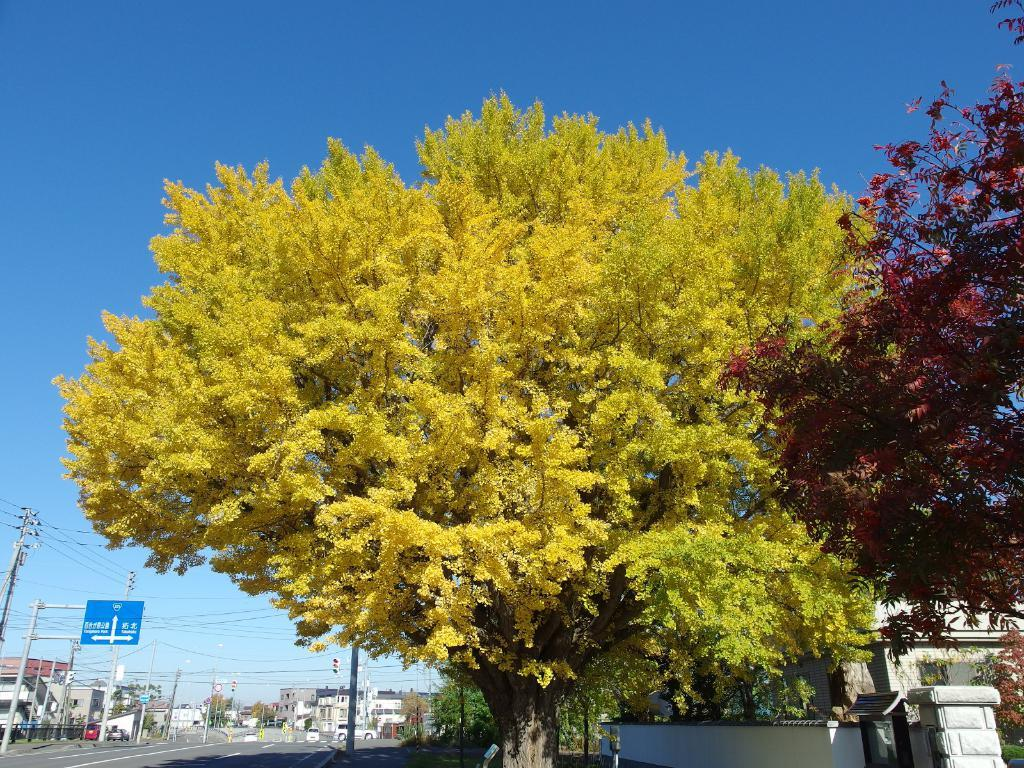What type of natural environment is visible in the image? There are many trees in the image, indicating a natural environment. What type of man-made structure can be seen in the image? There is a street in the image, which is a man-made structure. What device is used to control traffic in the image? There is a traffic signal in the image, which is used to control traffic. What type of information might be conveyed by the sign board in the image? The sign board in the image might convey information about directions, warnings, or advertisements. What type of transportation is visible in the image? There are vehicles in the image, which are used for transportation. Where is the cemetery located in the image? There is no cemetery present in the image. What type of wheel is used by the vehicles in the image? The vehicles in the image do not have wheels visible, but it can be assumed that they use wheels for transportation. 